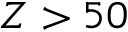Convert formula to latex. <formula><loc_0><loc_0><loc_500><loc_500>Z > 5 0</formula> 